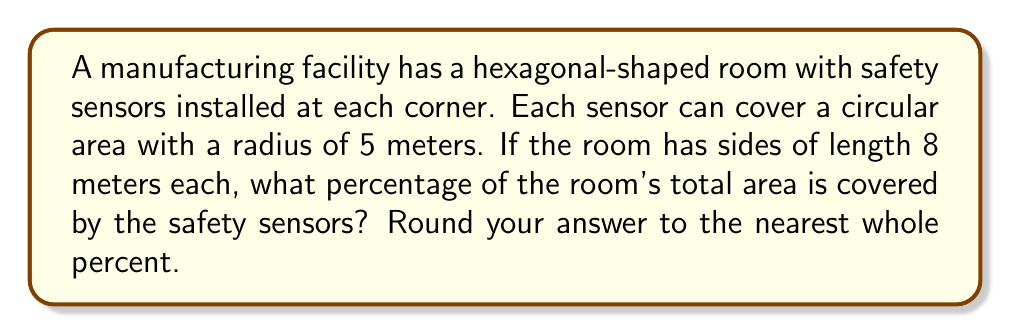What is the answer to this math problem? Let's approach this step-by-step:

1) First, we need to calculate the area of the hexagonal room:
   Area of a regular hexagon = $\frac{3\sqrt{3}}{2}s^2$, where s is the side length
   $$A_{room} = \frac{3\sqrt{3}}{2}(8^2) = 166.28 \text{ m}^2$$

2) Next, we need to calculate the area covered by each sensor:
   Area of a circle = $\pi r^2$
   $$A_{sensor} = \pi(5^2) = 78.54 \text{ m}^2$$

3) There are 6 sensors in total, so the total area covered by sensors is:
   $$A_{total\_covered} = 6 \times 78.54 = 471.24 \text{ m}^2$$

4) However, this is more than the room's area because the sensor coverage areas overlap. To visualize this, we can use Asymptote:

[asy]
import geometry;

pair[] vertices = {(0,0), (8,0), (12,6.93), (8,13.86), (0,13.86), (-4,6.93)};
path hexagon = polygon(vertices);

for(int i = 0; i < 6; ++i) {
  draw(circle(vertices[i], 5), rgb(0.7,0.7,1));
}
draw(hexagon, rgb(0,0,0)+linewidth(1));

[/asy]

5) To find the actual covered area, we need to find the area of the union of these circles within the hexagon. This is a complex calculation, but we can approximate it by considering the hexagon's area minus the uncovered corners.

6) The uncovered area in each corner is approximately a triangle. The height of this triangle is the difference between the hexagon's apothem and the sensor radius:
   Apothem of hexagon = $\frac{s\sqrt{3}}{2} = \frac{8\sqrt{3}}{2} = 6.93 \text{ m}$
   Uncovered height = $6.93 - 5 = 1.93 \text{ m}$

7) The base of this triangle can be approximated as $2 \times 1.93 = 3.86 \text{ m}$

8) Area of each uncovered triangle: $\frac{1}{2} \times 3.86 \times 1.93 = 3.72 \text{ m}^2$

9) Total uncovered area: $6 \times 3.72 = 22.32 \text{ m}^2$

10) Approximate covered area: $166.28 - 22.32 = 143.96 \text{ m}^2$

11) Percentage covered: $\frac{143.96}{166.28} \times 100 = 86.57\%$

Rounded to the nearest whole percent: 87%
Answer: 87% 